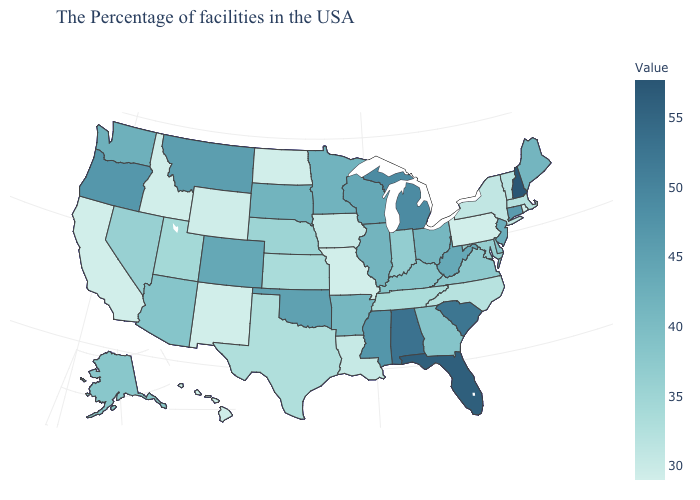Which states have the lowest value in the USA?
Be succinct. Rhode Island, Pennsylvania, Missouri, North Dakota, New Mexico, Idaho, California. Among the states that border Nevada , which have the lowest value?
Give a very brief answer. Idaho, California. 